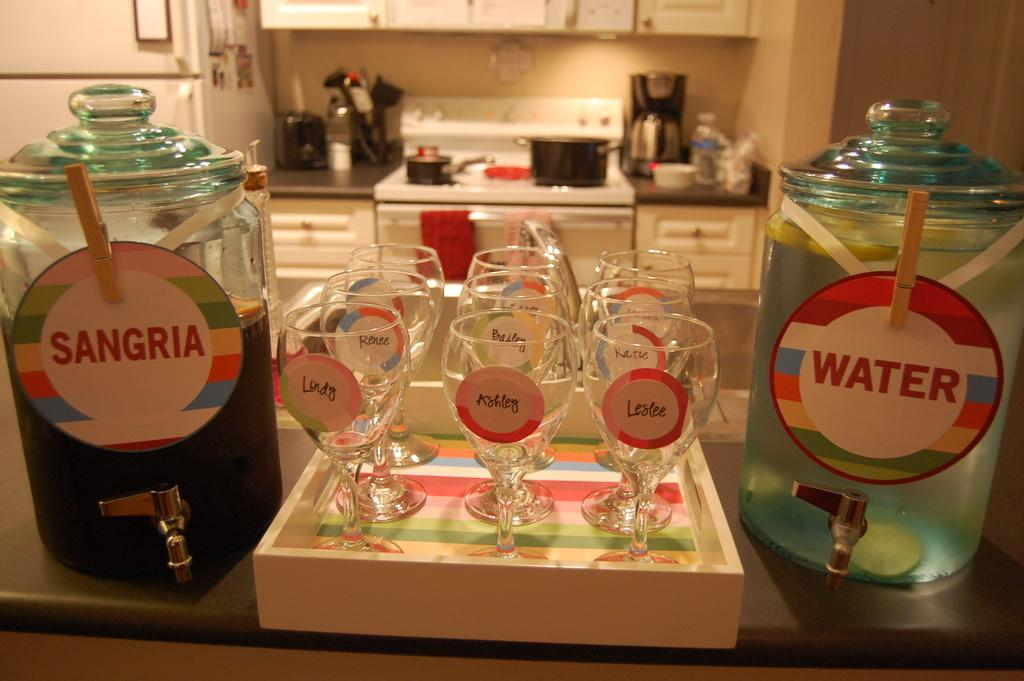<image>
Relay a brief, clear account of the picture shown. Jar of water and sangria with glass cups in between. 